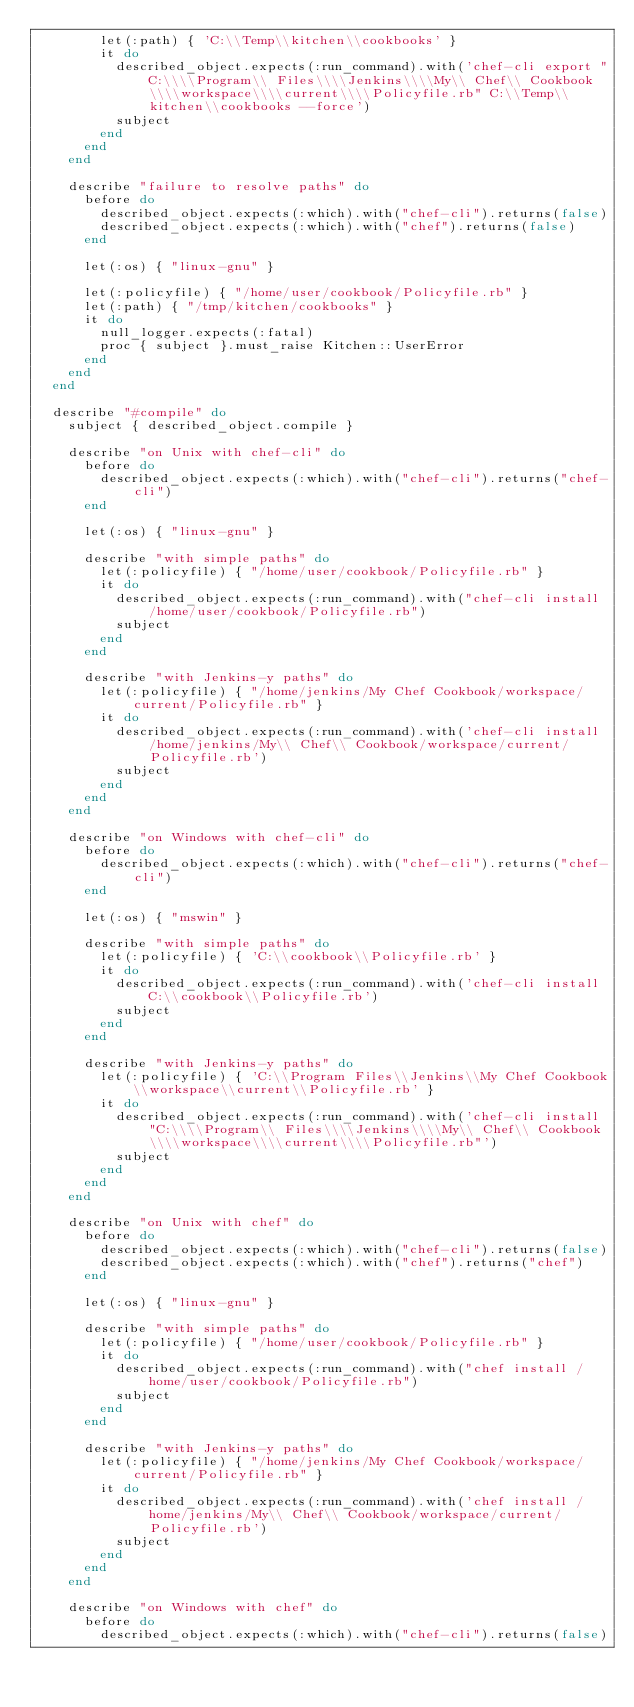<code> <loc_0><loc_0><loc_500><loc_500><_Ruby_>        let(:path) { 'C:\\Temp\\kitchen\\cookbooks' }
        it do
          described_object.expects(:run_command).with('chef-cli export "C:\\\\Program\\ Files\\\\Jenkins\\\\My\\ Chef\\ Cookbook\\\\workspace\\\\current\\\\Policyfile.rb" C:\\Temp\\kitchen\\cookbooks --force')
          subject
        end
      end
    end

    describe "failure to resolve paths" do
      before do
        described_object.expects(:which).with("chef-cli").returns(false)
        described_object.expects(:which).with("chef").returns(false)
      end

      let(:os) { "linux-gnu" }

      let(:policyfile) { "/home/user/cookbook/Policyfile.rb" }
      let(:path) { "/tmp/kitchen/cookbooks" }
      it do
        null_logger.expects(:fatal)
        proc { subject }.must_raise Kitchen::UserError
      end
    end
  end

  describe "#compile" do
    subject { described_object.compile }

    describe "on Unix with chef-cli" do
      before do
        described_object.expects(:which).with("chef-cli").returns("chef-cli")
      end

      let(:os) { "linux-gnu" }

      describe "with simple paths" do
        let(:policyfile) { "/home/user/cookbook/Policyfile.rb" }
        it do
          described_object.expects(:run_command).with("chef-cli install /home/user/cookbook/Policyfile.rb")
          subject
        end
      end

      describe "with Jenkins-y paths" do
        let(:policyfile) { "/home/jenkins/My Chef Cookbook/workspace/current/Policyfile.rb" }
        it do
          described_object.expects(:run_command).with('chef-cli install /home/jenkins/My\\ Chef\\ Cookbook/workspace/current/Policyfile.rb')
          subject
        end
      end
    end

    describe "on Windows with chef-cli" do
      before do
        described_object.expects(:which).with("chef-cli").returns("chef-cli")
      end

      let(:os) { "mswin" }

      describe "with simple paths" do
        let(:policyfile) { 'C:\\cookbook\\Policyfile.rb' }
        it do
          described_object.expects(:run_command).with('chef-cli install C:\\cookbook\\Policyfile.rb')
          subject
        end
      end

      describe "with Jenkins-y paths" do
        let(:policyfile) { 'C:\\Program Files\\Jenkins\\My Chef Cookbook\\workspace\\current\\Policyfile.rb' }
        it do
          described_object.expects(:run_command).with('chef-cli install "C:\\\\Program\\ Files\\\\Jenkins\\\\My\\ Chef\\ Cookbook\\\\workspace\\\\current\\\\Policyfile.rb"')
          subject
        end
      end
    end

    describe "on Unix with chef" do
      before do
        described_object.expects(:which).with("chef-cli").returns(false)
        described_object.expects(:which).with("chef").returns("chef")
      end

      let(:os) { "linux-gnu" }

      describe "with simple paths" do
        let(:policyfile) { "/home/user/cookbook/Policyfile.rb" }
        it do
          described_object.expects(:run_command).with("chef install /home/user/cookbook/Policyfile.rb")
          subject
        end
      end

      describe "with Jenkins-y paths" do
        let(:policyfile) { "/home/jenkins/My Chef Cookbook/workspace/current/Policyfile.rb" }
        it do
          described_object.expects(:run_command).with('chef install /home/jenkins/My\\ Chef\\ Cookbook/workspace/current/Policyfile.rb')
          subject
        end
      end
    end

    describe "on Windows with chef" do
      before do
        described_object.expects(:which).with("chef-cli").returns(false)</code> 